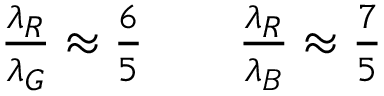Convert formula to latex. <formula><loc_0><loc_0><loc_500><loc_500>\begin{array} { r } { \frac { \lambda _ { R } } { \lambda _ { G } } \approx \frac { 6 } { 5 } \quad \frac { \lambda _ { R } } { \lambda _ { B } } \approx \frac { 7 } { 5 } } \end{array}</formula> 